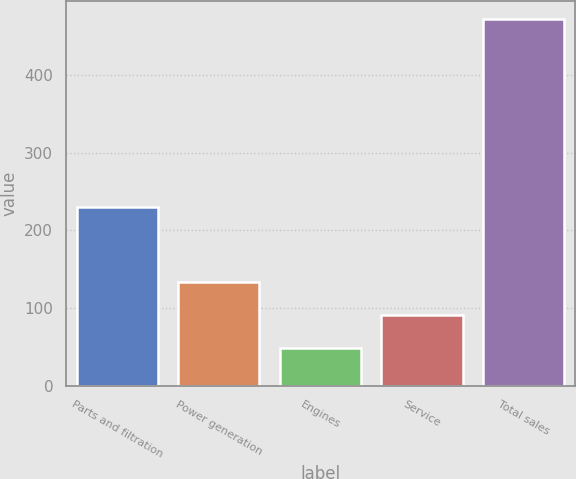Convert chart. <chart><loc_0><loc_0><loc_500><loc_500><bar_chart><fcel>Parts and filtration<fcel>Power generation<fcel>Engines<fcel>Service<fcel>Total sales<nl><fcel>230<fcel>132.8<fcel>48<fcel>90.4<fcel>472<nl></chart> 